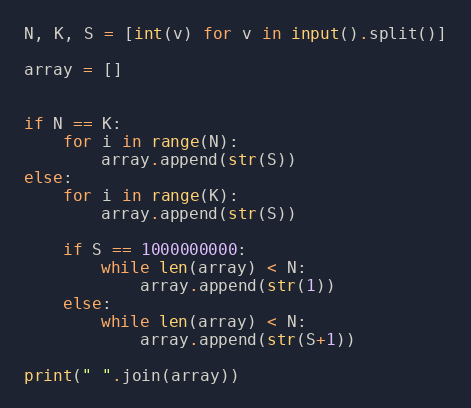Convert code to text. <code><loc_0><loc_0><loc_500><loc_500><_Python_>N, K, S = [int(v) for v in input().split()]

array = []

    
if N == K:
    for i in range(N):
        array.append(str(S))
else:
    for i in range(K):
        array.append(str(S))

    if S == 1000000000:
        while len(array) < N:
            array.append(str(1))
    else:
        while len(array) < N:
            array.append(str(S+1))

print(" ".join(array))

</code> 